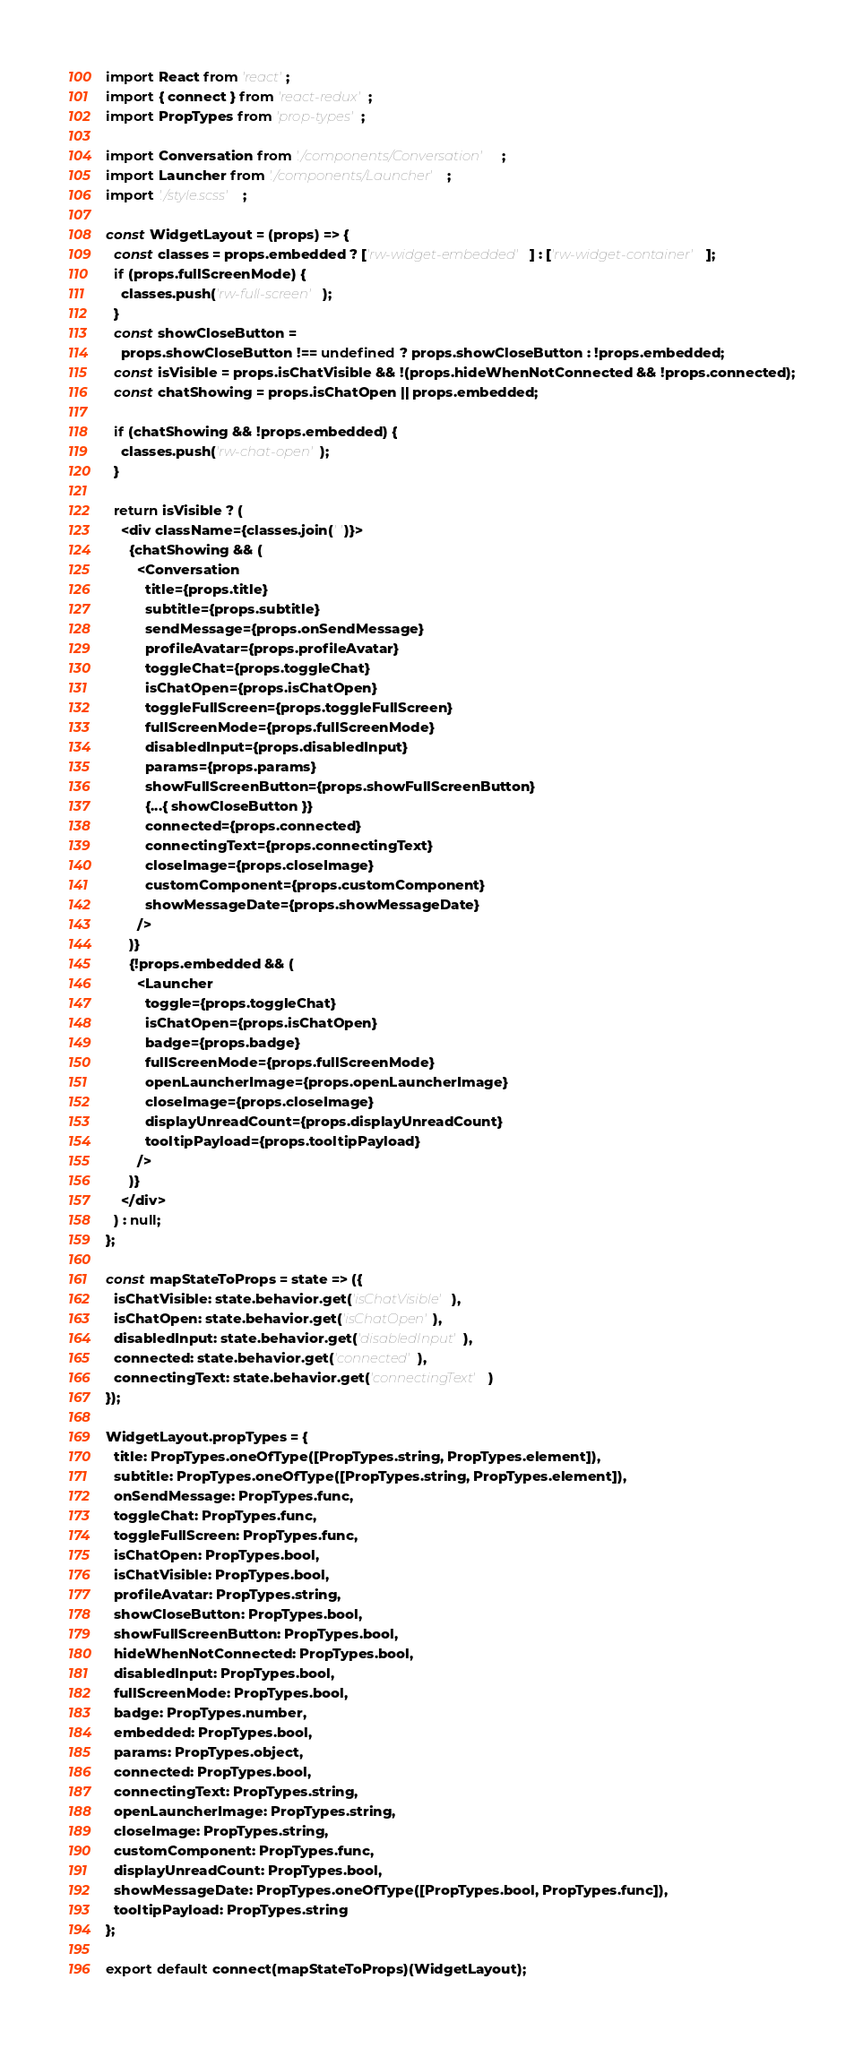Convert code to text. <code><loc_0><loc_0><loc_500><loc_500><_JavaScript_>import React from 'react';
import { connect } from 'react-redux';
import PropTypes from 'prop-types';

import Conversation from './components/Conversation';
import Launcher from './components/Launcher';
import './style.scss';

const WidgetLayout = (props) => {
  const classes = props.embedded ? ['rw-widget-embedded'] : ['rw-widget-container'];
  if (props.fullScreenMode) {
    classes.push('rw-full-screen');
  }
  const showCloseButton =
    props.showCloseButton !== undefined ? props.showCloseButton : !props.embedded;
  const isVisible = props.isChatVisible && !(props.hideWhenNotConnected && !props.connected);
  const chatShowing = props.isChatOpen || props.embedded;

  if (chatShowing && !props.embedded) {
    classes.push('rw-chat-open');
  }

  return isVisible ? (
    <div className={classes.join(' ')}>
      {chatShowing && (
        <Conversation
          title={props.title}
          subtitle={props.subtitle}
          sendMessage={props.onSendMessage}
          profileAvatar={props.profileAvatar}
          toggleChat={props.toggleChat}
          isChatOpen={props.isChatOpen}
          toggleFullScreen={props.toggleFullScreen}
          fullScreenMode={props.fullScreenMode}
          disabledInput={props.disabledInput}
          params={props.params}
          showFullScreenButton={props.showFullScreenButton}
          {...{ showCloseButton }}
          connected={props.connected}
          connectingText={props.connectingText}
          closeImage={props.closeImage}
          customComponent={props.customComponent}
          showMessageDate={props.showMessageDate}
        />
      )}
      {!props.embedded && (
        <Launcher
          toggle={props.toggleChat}
          isChatOpen={props.isChatOpen}
          badge={props.badge}
          fullScreenMode={props.fullScreenMode}
          openLauncherImage={props.openLauncherImage}
          closeImage={props.closeImage}
          displayUnreadCount={props.displayUnreadCount}
          tooltipPayload={props.tooltipPayload}
        />
      )}
    </div>
  ) : null;
};

const mapStateToProps = state => ({
  isChatVisible: state.behavior.get('isChatVisible'),
  isChatOpen: state.behavior.get('isChatOpen'),
  disabledInput: state.behavior.get('disabledInput'),
  connected: state.behavior.get('connected'),
  connectingText: state.behavior.get('connectingText')
});

WidgetLayout.propTypes = {
  title: PropTypes.oneOfType([PropTypes.string, PropTypes.element]),
  subtitle: PropTypes.oneOfType([PropTypes.string, PropTypes.element]),
  onSendMessage: PropTypes.func,
  toggleChat: PropTypes.func,
  toggleFullScreen: PropTypes.func,
  isChatOpen: PropTypes.bool,
  isChatVisible: PropTypes.bool,
  profileAvatar: PropTypes.string,
  showCloseButton: PropTypes.bool,
  showFullScreenButton: PropTypes.bool,
  hideWhenNotConnected: PropTypes.bool,
  disabledInput: PropTypes.bool,
  fullScreenMode: PropTypes.bool,
  badge: PropTypes.number,
  embedded: PropTypes.bool,
  params: PropTypes.object,
  connected: PropTypes.bool,
  connectingText: PropTypes.string,
  openLauncherImage: PropTypes.string,
  closeImage: PropTypes.string,
  customComponent: PropTypes.func,
  displayUnreadCount: PropTypes.bool,
  showMessageDate: PropTypes.oneOfType([PropTypes.bool, PropTypes.func]),
  tooltipPayload: PropTypes.string
};

export default connect(mapStateToProps)(WidgetLayout);
</code> 